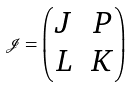Convert formula to latex. <formula><loc_0><loc_0><loc_500><loc_500>\mathcal { J } = \begin{pmatrix} J & P \\ L & K \end{pmatrix}</formula> 